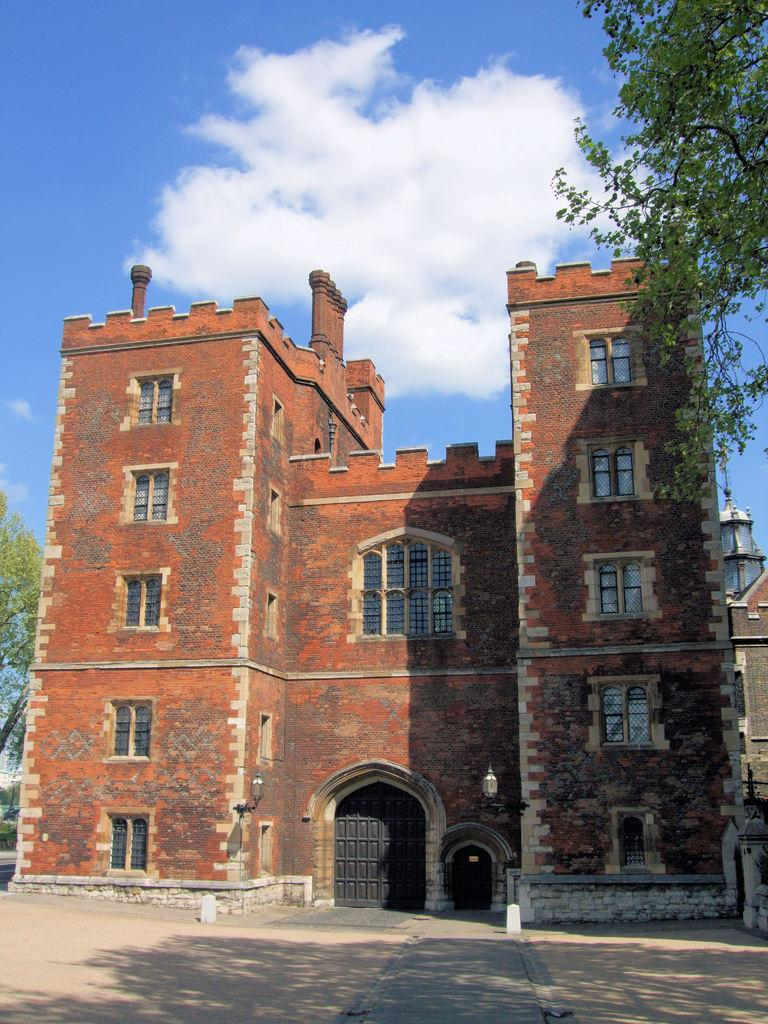What is the main subject in the center of the image? There is a building in the center of the image. What can be seen in the background of the image? There are trees and lights in the background of the image. What is visible at the top of the image? There are clouds visible at the top of the image. What is visible at the bottom of the image? There is a road visible at the bottom of the image. Can you see a veil being offered to someone in the image? There is no veil or offering present in the image. Is there a guitar being played in the image? There is no guitar or musician present in the image. 